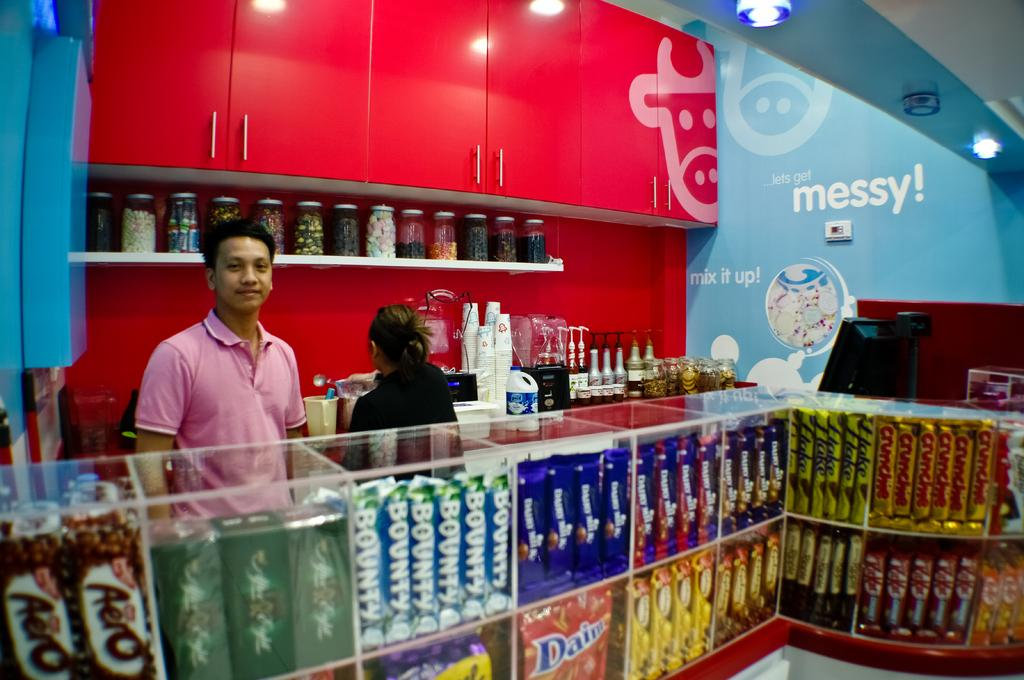<image>
Relay a brief, clear account of the picture shown. A person is behind the counter at a candy story that has "lets get messy" written on the wall. 